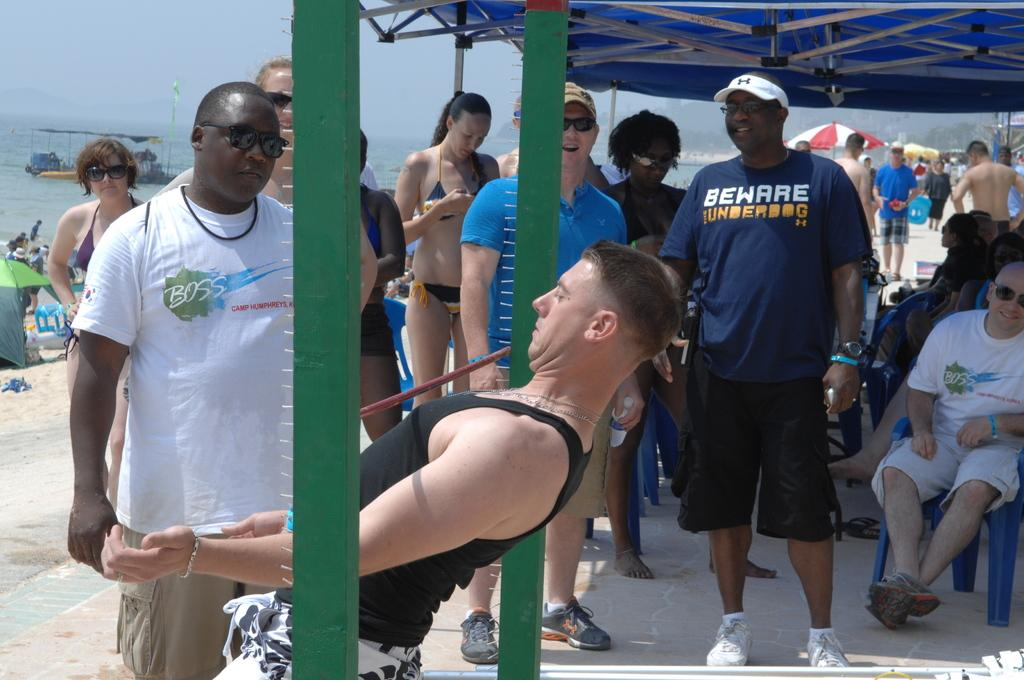What are the people in the image doing? Some people are standing, and some are sitting in the image. What can be seen in the background of the image? The sea, a boat, a parasol, and the sky are visible in the background of the image. What type of straw is being used by the people in the image? There is no straw present in the image; it is not mentioned in the provided facts. 